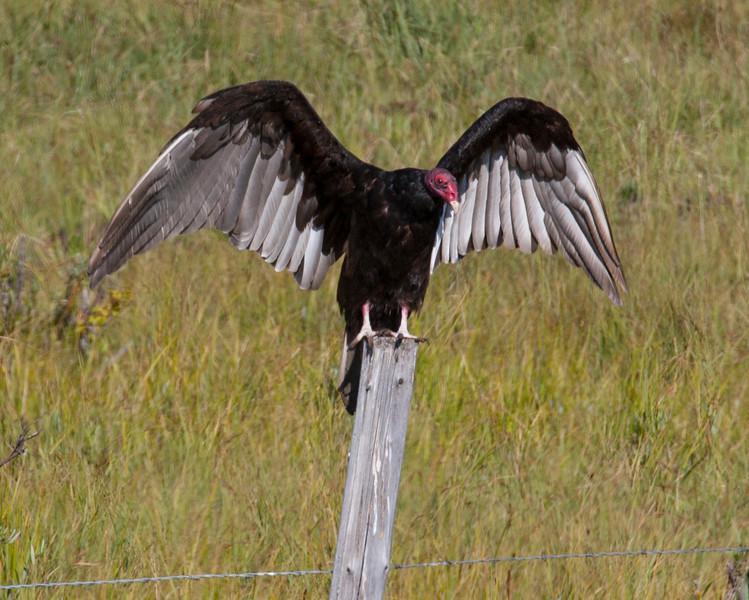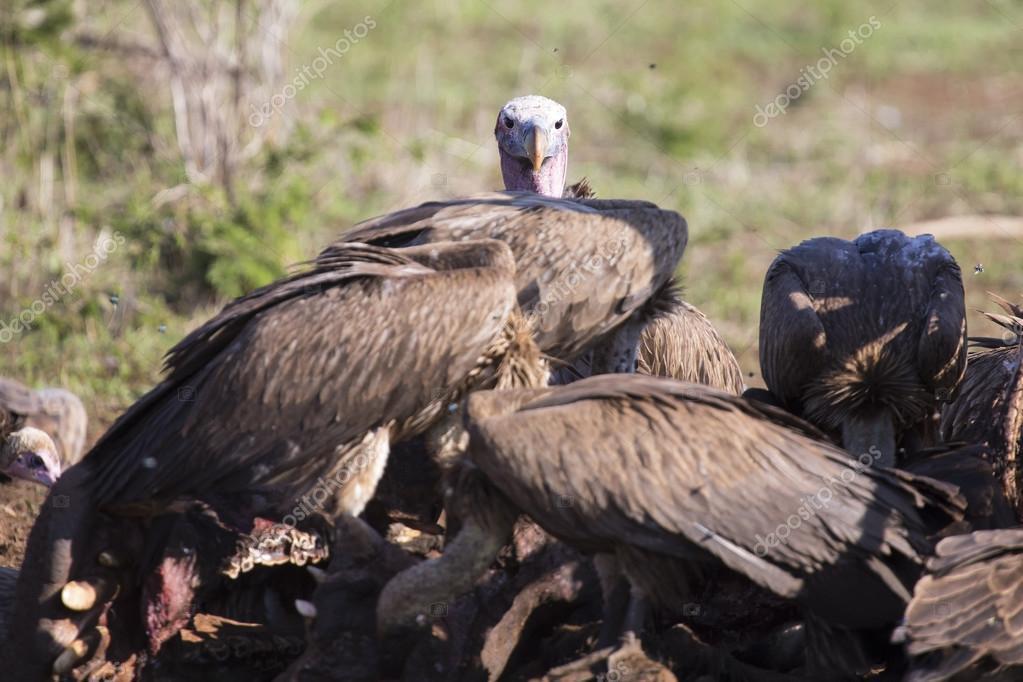The first image is the image on the left, the second image is the image on the right. Examine the images to the left and right. Is the description "The bird in the image on the left has its wings spread wide." accurate? Answer yes or no. Yes. The first image is the image on the left, the second image is the image on the right. Evaluate the accuracy of this statement regarding the images: "An image contains just one bird, perched with outspread wings on an object that is not a tree branch.". Is it true? Answer yes or no. Yes. 